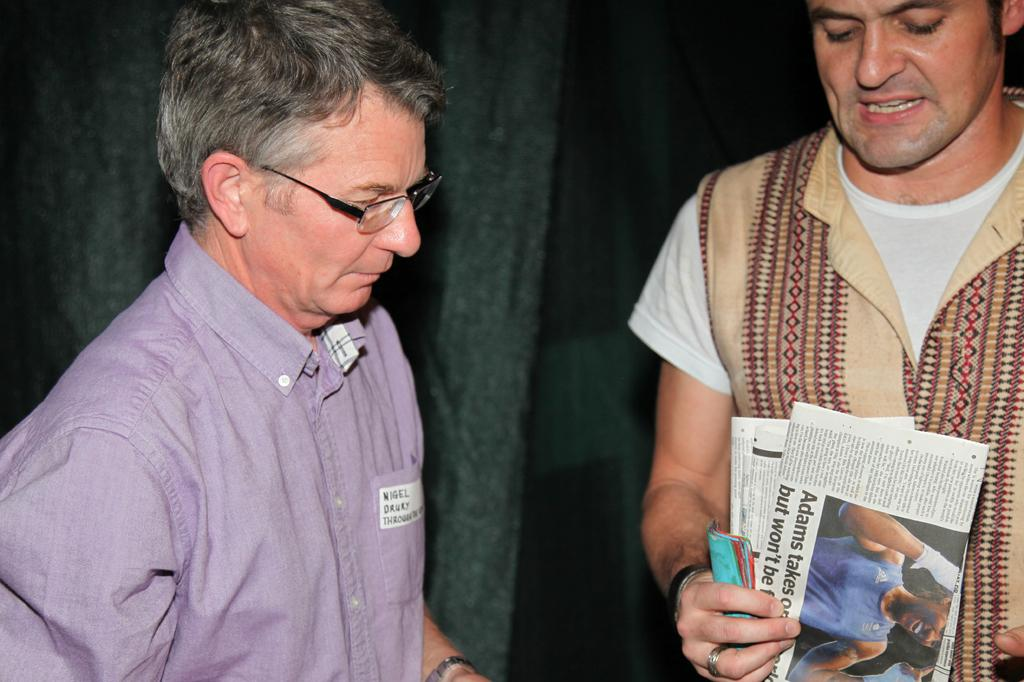How many men are present in the image? There are two men in the image. Can you describe the position of each man? One man is standing on the right side, and the other man is standing on the left side. What is the man on the right side holding? The man on the right side is holding some papers. What can be observed about the man on the left side? The man on the left side is wearing spectacles. What type of lock is being used to secure the answer in the image? There is no lock or answer present in the image; it features two men, one holding papers and the other wearing spectacles. 